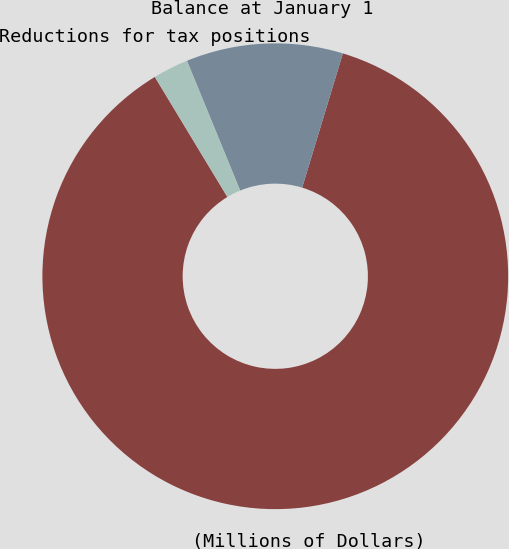Convert chart to OTSL. <chart><loc_0><loc_0><loc_500><loc_500><pie_chart><fcel>(Millions of Dollars)<fcel>Balance at January 1<fcel>Reductions for tax positions<nl><fcel>86.67%<fcel>10.88%<fcel>2.46%<nl></chart> 